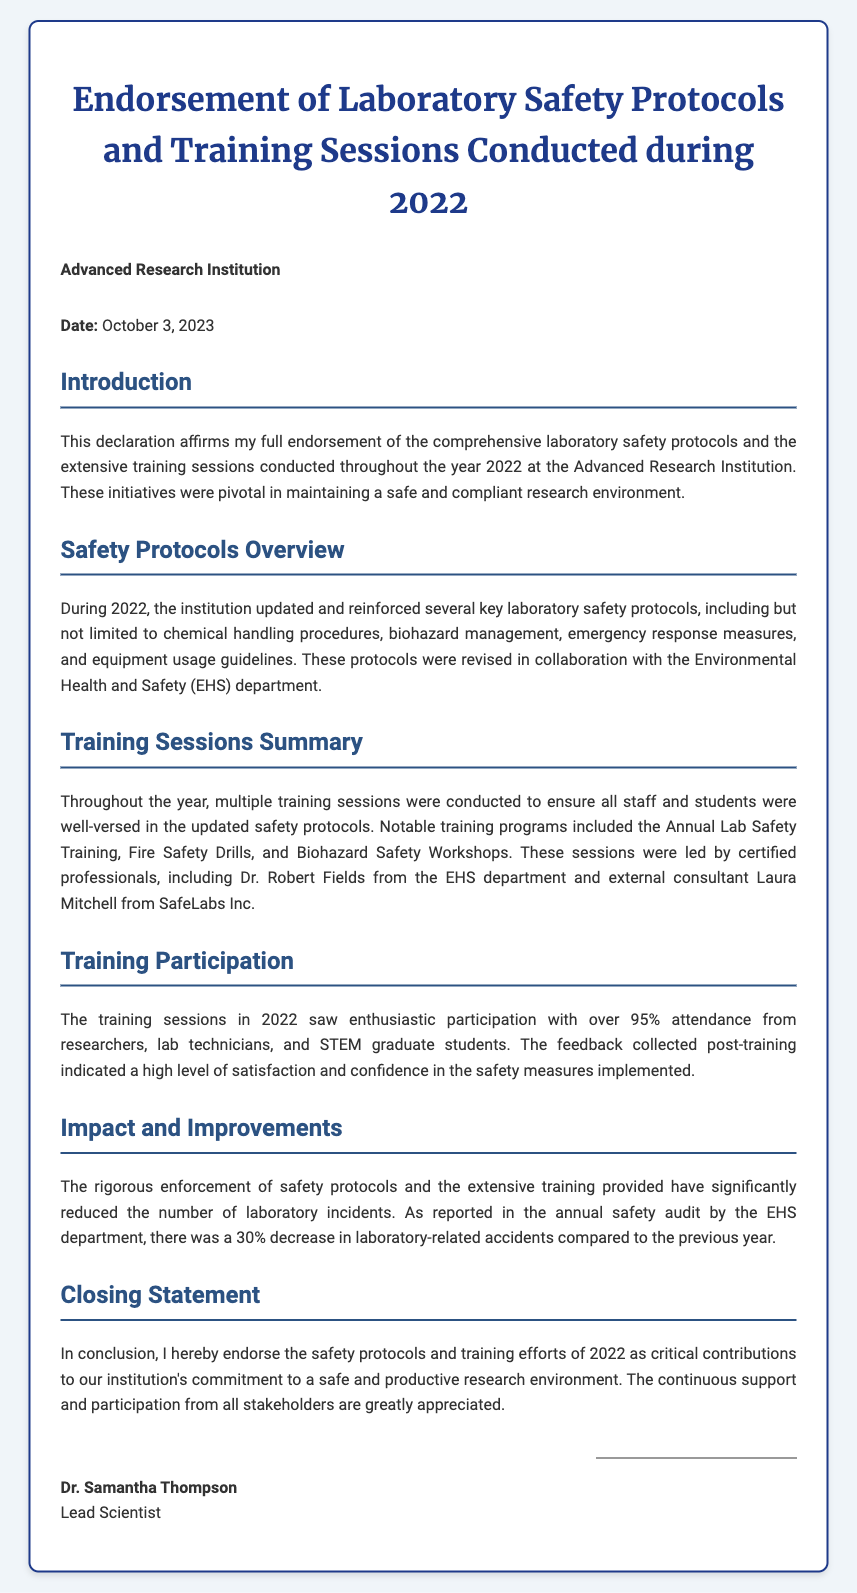What is the date of the declaration? The date of the declaration is stated at the beginning of the document as October 3, 2023.
Answer: October 3, 2023 Who is the lead scientist? The document mentions Dr. Samantha Thompson as the lead scientist at the end of the declaration.
Answer: Dr. Samantha Thompson What is the percentage of attendance for training sessions? The participation in the training sessions is reported to be over 95%, indicating high attendance.
Answer: over 95% What was the decrease in laboratory-related accidents? The document states that there was a 30% decrease in laboratory-related accidents compared to the previous year.
Answer: 30% Which department collaborated on safety protocol revisions? The Environmental Health and Safety department is identified as the collaborating department for safety protocol revisions.
Answer: Environmental Health and Safety (EHS) What type of workshops were included in the training sessions? Biohazard Safety Workshops are specifically mentioned as part of the training sessions conducted in 2022.
Answer: Biohazard Safety Workshops What was the main goal of the training sessions conducted? The training sessions aimed to ensure that all staff and students were well-versed in the updated safety protocols.
Answer: updated safety protocols Who led the training sessions? Dr. Robert Fields from the EHS department and Laura Mitchell from SafeLabs Inc. are highlighted as leading the training sessions.
Answer: Dr. Robert Fields and Laura Mitchell 